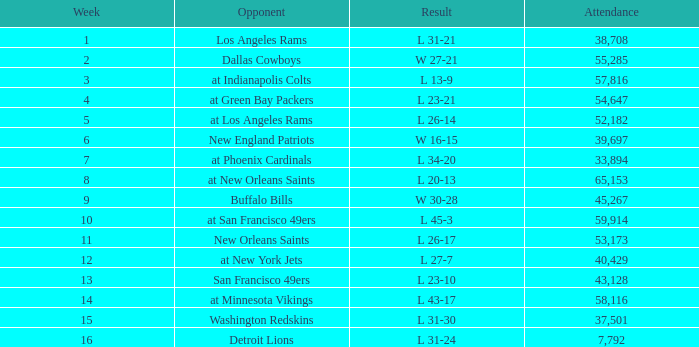The Detroit Lions were played against what week? 16.0. 